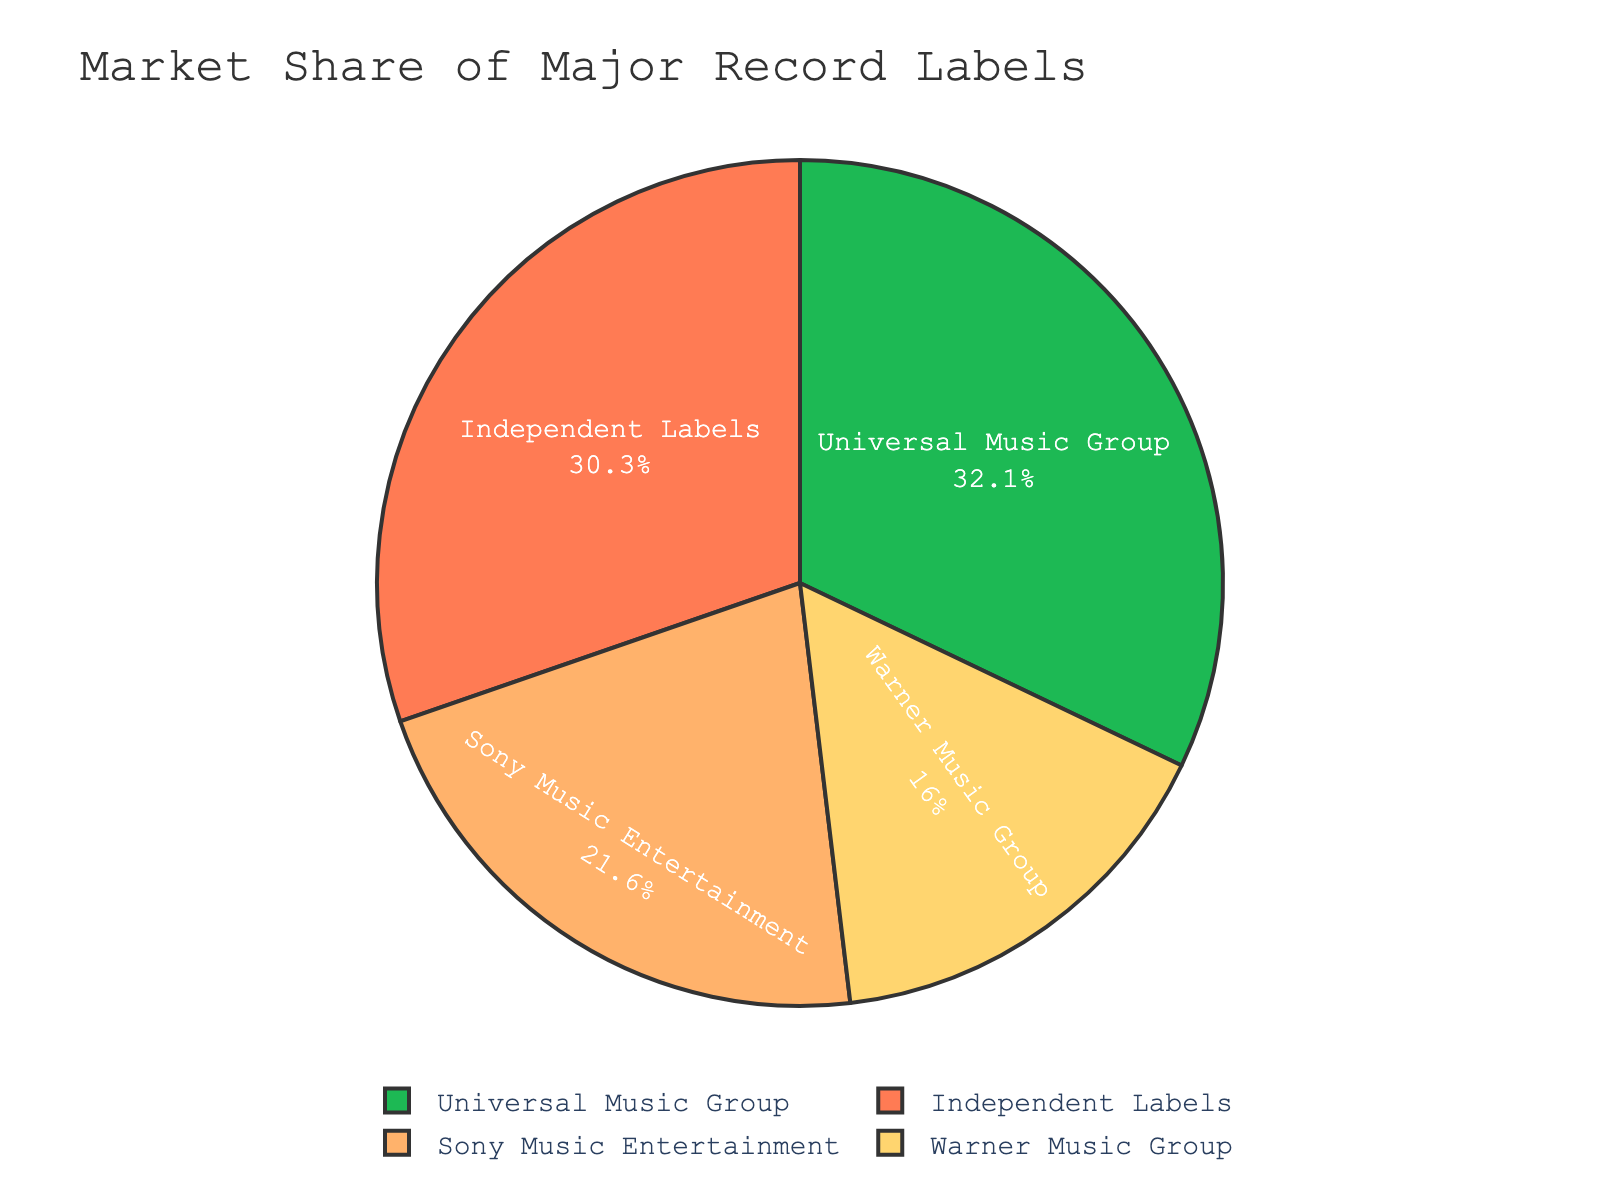Which record label has the largest market share? Look at the pie chart and identify which segment is the largest. The largest segment is labeled "Universal Music Group" with 32.1%.
Answer: Universal Music Group What is the combined market share of Universal Music Group and Warner Music Group? Add the market shares of Universal Music Group (32.1%) and Warner Music Group (16.0%). 32.1 + 16.0 = 48.1
Answer: 48.1% Which label has a larger market share, Sony Music Entertainment or Warner Music Group? Compare the market shares of Sony Music Entertainment (21.6%) and Warner Music Group (16.0%). Sony Music Entertainment has a larger share.
Answer: Sony Music Entertainment What percentage of the market is held by independent labels? Look at the label "Independent Labels" in the chart, which states 30.3%.
Answer: 30.3% Is the market share of Sony Music Entertainment closer to that of Universal Music Group or Warner Music Group? Calculate the difference between Sony Music Entertainment (21.6%) and both Universal Music Group (32.1%) and Warner Music Group (16.0%). The differences are: 32.1 - 21.6 = 10.5 and 21.6 - 16.0 = 5.6. The smaller difference is with Warner Music Group.
Answer: Warner Music Group What is the difference in market share between Universal Music Group and Independent Labels? Subtract the market share of Independent Labels (30.3%) from Universal Music Group (32.1%). 32.1 - 30.3 = 1.8
Answer: 1.8% Rank the record labels from highest to lowest market share. Organize the labels by their market shares: Universal Music Group (32.1%), Independent Labels (30.3%), Sony Music Entertainment (21.6%), Warner Music Group (16.0%).
Answer: Universal Music Group > Independent Labels > Sony Music Entertainment > Warner Music Group What is the average market share of the major record labels excluding independent labels? Add the market shares of Universal Music Group (32.1%), Sony Music Entertainment (21.6%), and Warner Music Group (16.0%). Then divide by 3. (32.1 + 21.6 + 16.0)/3 = 23.23
Answer: 23.23% Which segment has a green color in the pie chart? Identify the segment with the green color. According to the color scheme, the first color '#1DB954' is green, which corresponds to "Universal Music Group".
Answer: Universal Music Group By how much does the market share of Universal Music Group exceed the combined market share of Warner Music Group and Independent Labels? Add the market shares of Warner Music Group (16.0%) and Independent Labels (30.3%) to get 46.3%. Then subtract that from Universal Music Group's market share, 32.1 - 46.3 = -14.2. The share doesn’t exceed, it’s actually 14.2% less.
Answer: -14.2% 